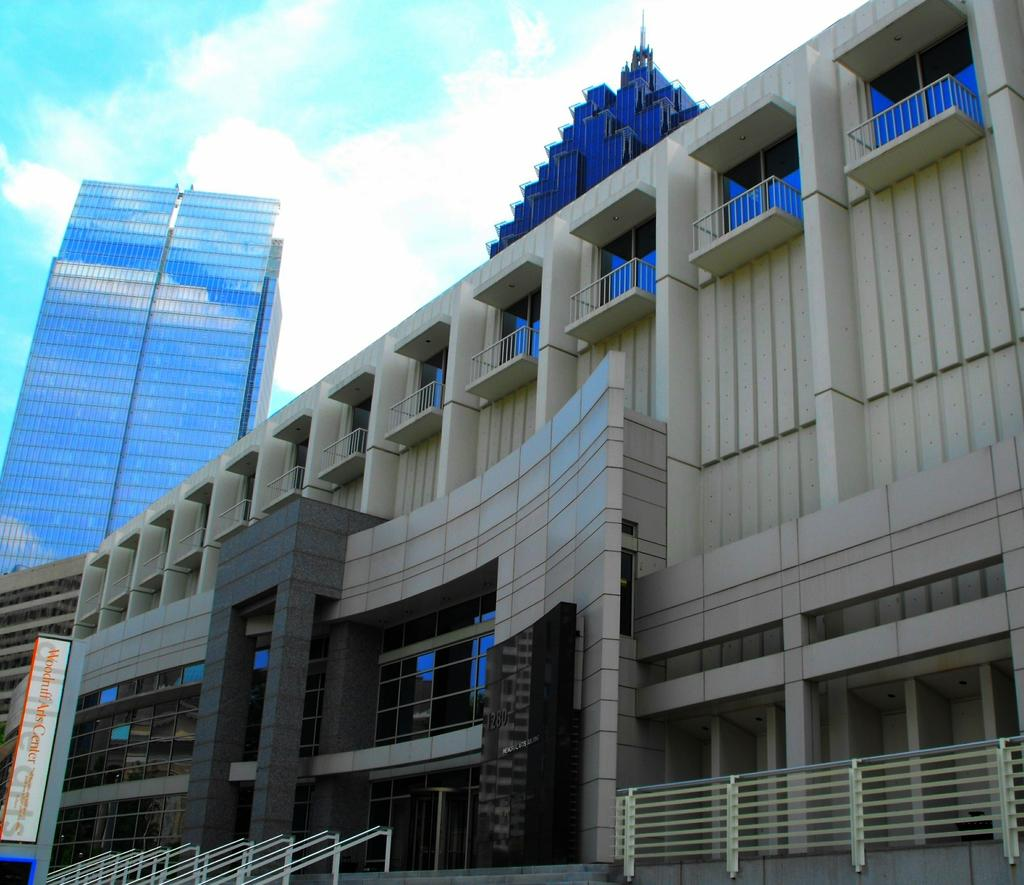What is located in the foreground of the image? There is a railing and a building in the foreground of the image. What type of structures are present in the foreground of the image? Skyscrapers are present in the foreground of the image. What can be seen in the background of the image? The sky is visible in the image. What is the condition of the sky in the image? Clouds are present in the sky. What title is written on the railing in the image? There is no title written on the railing in the image. Is there a bulb visible in the image? There is no bulb present in the image. Can you see any bombs in the image? There are no bombs present in the image. 